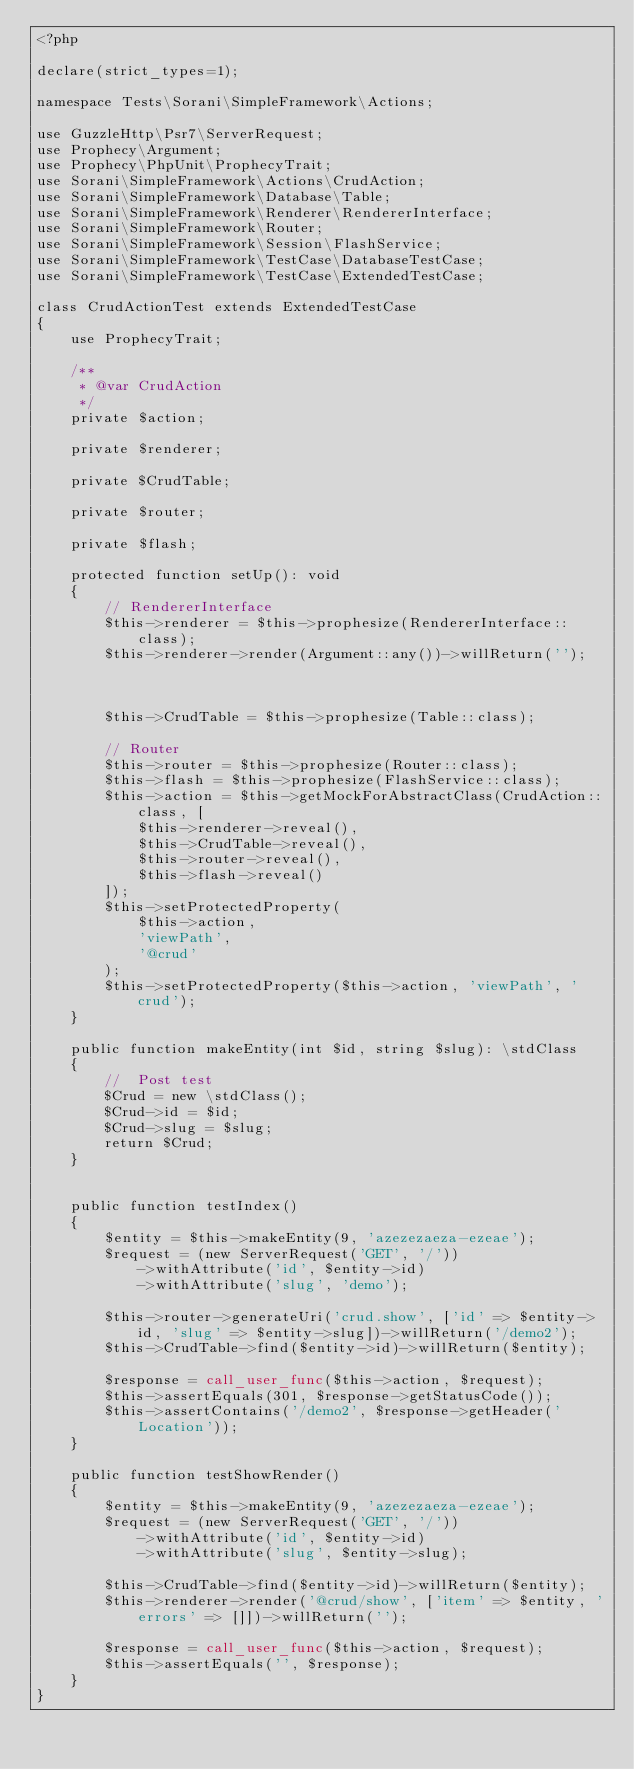Convert code to text. <code><loc_0><loc_0><loc_500><loc_500><_PHP_><?php

declare(strict_types=1);

namespace Tests\Sorani\SimpleFramework\Actions;

use GuzzleHttp\Psr7\ServerRequest;
use Prophecy\Argument;
use Prophecy\PhpUnit\ProphecyTrait;
use Sorani\SimpleFramework\Actions\CrudAction;
use Sorani\SimpleFramework\Database\Table;
use Sorani\SimpleFramework\Renderer\RendererInterface;
use Sorani\SimpleFramework\Router;
use Sorani\SimpleFramework\Session\FlashService;
use Sorani\SimpleFramework\TestCase\DatabaseTestCase;
use Sorani\SimpleFramework\TestCase\ExtendedTestCase;

class CrudActionTest extends ExtendedTestCase
{
    use ProphecyTrait;

    /**
     * @var CrudAction
     */
    private $action;

    private $renderer;

    private $CrudTable;

    private $router;

    private $flash;

    protected function setUp(): void
    {
        // RendererInterface
        $this->renderer = $this->prophesize(RendererInterface::class);
        $this->renderer->render(Argument::any())->willReturn('');



        $this->CrudTable = $this->prophesize(Table::class);

        // Router
        $this->router = $this->prophesize(Router::class);
        $this->flash = $this->prophesize(FlashService::class);
        $this->action = $this->getMockForAbstractClass(CrudAction::class, [
            $this->renderer->reveal(),
            $this->CrudTable->reveal(),
            $this->router->reveal(),
            $this->flash->reveal()
        ]);
        $this->setProtectedProperty(
            $this->action,
            'viewPath',
            '@crud'
        );
        $this->setProtectedProperty($this->action, 'viewPath', 'crud');
    }

    public function makeEntity(int $id, string $slug): \stdClass
    {
        //  Post test
        $Crud = new \stdClass();
        $Crud->id = $id;
        $Crud->slug = $slug;
        return $Crud;
    }


    public function testIndex()
    {
        $entity = $this->makeEntity(9, 'azezezaeza-ezeae');
        $request = (new ServerRequest('GET', '/'))
            ->withAttribute('id', $entity->id)
            ->withAttribute('slug', 'demo');

        $this->router->generateUri('crud.show', ['id' => $entity->id, 'slug' => $entity->slug])->willReturn('/demo2');
        $this->CrudTable->find($entity->id)->willReturn($entity);

        $response = call_user_func($this->action, $request);
        $this->assertEquals(301, $response->getStatusCode());
        $this->assertContains('/demo2', $response->getHeader('Location'));
    }

    public function testShowRender()
    {
        $entity = $this->makeEntity(9, 'azezezaeza-ezeae');
        $request = (new ServerRequest('GET', '/'))
            ->withAttribute('id', $entity->id)
            ->withAttribute('slug', $entity->slug);

        $this->CrudTable->find($entity->id)->willReturn($entity);
        $this->renderer->render('@crud/show', ['item' => $entity, 'errors' => []])->willReturn('');

        $response = call_user_func($this->action, $request);
        $this->assertEquals('', $response);
    }
}
</code> 